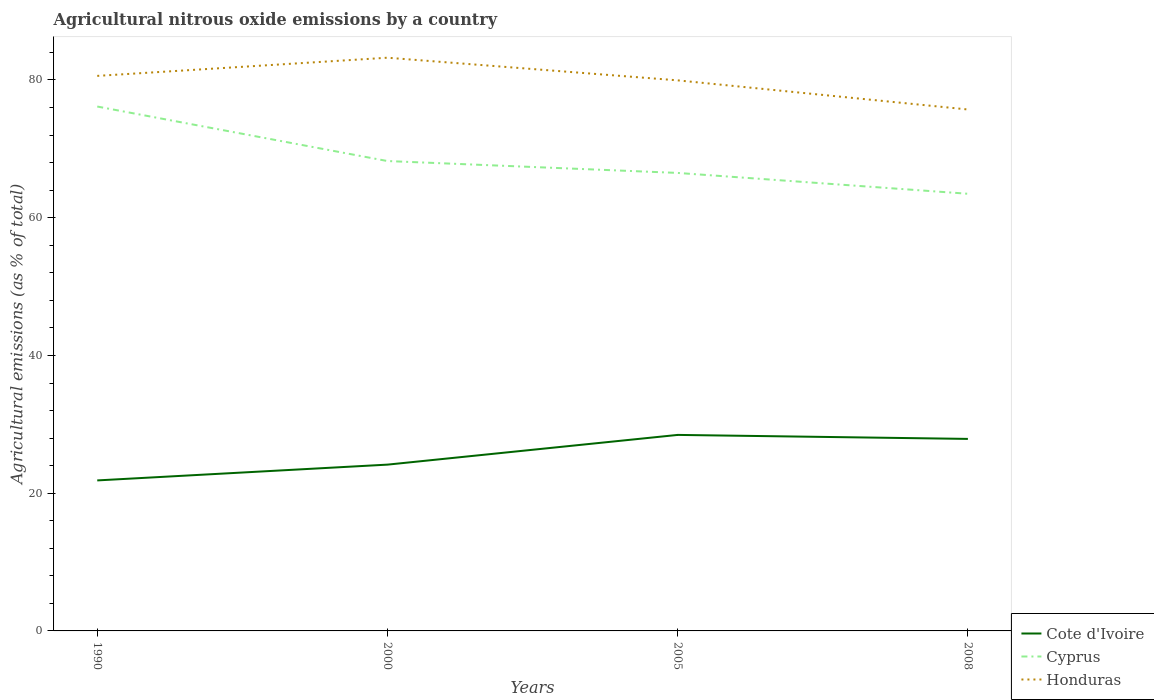How many different coloured lines are there?
Provide a succinct answer. 3. Across all years, what is the maximum amount of agricultural nitrous oxide emitted in Honduras?
Provide a short and direct response. 75.72. In which year was the amount of agricultural nitrous oxide emitted in Honduras maximum?
Your answer should be compact. 2008. What is the total amount of agricultural nitrous oxide emitted in Cote d'Ivoire in the graph?
Give a very brief answer. -4.31. What is the difference between the highest and the second highest amount of agricultural nitrous oxide emitted in Cyprus?
Provide a succinct answer. 12.67. What is the difference between the highest and the lowest amount of agricultural nitrous oxide emitted in Cote d'Ivoire?
Offer a very short reply. 2. Is the amount of agricultural nitrous oxide emitted in Honduras strictly greater than the amount of agricultural nitrous oxide emitted in Cyprus over the years?
Give a very brief answer. No. What is the difference between two consecutive major ticks on the Y-axis?
Keep it short and to the point. 20. Are the values on the major ticks of Y-axis written in scientific E-notation?
Your answer should be compact. No. Does the graph contain any zero values?
Provide a short and direct response. No. How many legend labels are there?
Keep it short and to the point. 3. What is the title of the graph?
Your answer should be very brief. Agricultural nitrous oxide emissions by a country. What is the label or title of the X-axis?
Make the answer very short. Years. What is the label or title of the Y-axis?
Your answer should be very brief. Agricultural emissions (as % of total). What is the Agricultural emissions (as % of total) in Cote d'Ivoire in 1990?
Your response must be concise. 21.85. What is the Agricultural emissions (as % of total) of Cyprus in 1990?
Your answer should be very brief. 76.14. What is the Agricultural emissions (as % of total) in Honduras in 1990?
Give a very brief answer. 80.59. What is the Agricultural emissions (as % of total) of Cote d'Ivoire in 2000?
Provide a short and direct response. 24.15. What is the Agricultural emissions (as % of total) in Cyprus in 2000?
Provide a short and direct response. 68.23. What is the Agricultural emissions (as % of total) of Honduras in 2000?
Offer a very short reply. 83.23. What is the Agricultural emissions (as % of total) in Cote d'Ivoire in 2005?
Your response must be concise. 28.46. What is the Agricultural emissions (as % of total) in Cyprus in 2005?
Offer a very short reply. 66.5. What is the Agricultural emissions (as % of total) in Honduras in 2005?
Offer a terse response. 79.95. What is the Agricultural emissions (as % of total) of Cote d'Ivoire in 2008?
Your response must be concise. 27.88. What is the Agricultural emissions (as % of total) in Cyprus in 2008?
Your answer should be very brief. 63.48. What is the Agricultural emissions (as % of total) of Honduras in 2008?
Keep it short and to the point. 75.72. Across all years, what is the maximum Agricultural emissions (as % of total) of Cote d'Ivoire?
Offer a very short reply. 28.46. Across all years, what is the maximum Agricultural emissions (as % of total) of Cyprus?
Your answer should be compact. 76.14. Across all years, what is the maximum Agricultural emissions (as % of total) in Honduras?
Offer a very short reply. 83.23. Across all years, what is the minimum Agricultural emissions (as % of total) of Cote d'Ivoire?
Provide a succinct answer. 21.85. Across all years, what is the minimum Agricultural emissions (as % of total) in Cyprus?
Provide a short and direct response. 63.48. Across all years, what is the minimum Agricultural emissions (as % of total) in Honduras?
Your response must be concise. 75.72. What is the total Agricultural emissions (as % of total) of Cote d'Ivoire in the graph?
Provide a short and direct response. 102.34. What is the total Agricultural emissions (as % of total) in Cyprus in the graph?
Provide a short and direct response. 274.36. What is the total Agricultural emissions (as % of total) in Honduras in the graph?
Offer a terse response. 319.49. What is the difference between the Agricultural emissions (as % of total) of Cote d'Ivoire in 1990 and that in 2000?
Offer a terse response. -2.29. What is the difference between the Agricultural emissions (as % of total) in Cyprus in 1990 and that in 2000?
Your answer should be very brief. 7.92. What is the difference between the Agricultural emissions (as % of total) in Honduras in 1990 and that in 2000?
Your response must be concise. -2.64. What is the difference between the Agricultural emissions (as % of total) in Cote d'Ivoire in 1990 and that in 2005?
Keep it short and to the point. -6.61. What is the difference between the Agricultural emissions (as % of total) of Cyprus in 1990 and that in 2005?
Your answer should be very brief. 9.64. What is the difference between the Agricultural emissions (as % of total) in Honduras in 1990 and that in 2005?
Offer a very short reply. 0.65. What is the difference between the Agricultural emissions (as % of total) of Cote d'Ivoire in 1990 and that in 2008?
Your answer should be very brief. -6.03. What is the difference between the Agricultural emissions (as % of total) of Cyprus in 1990 and that in 2008?
Offer a terse response. 12.67. What is the difference between the Agricultural emissions (as % of total) in Honduras in 1990 and that in 2008?
Ensure brevity in your answer.  4.88. What is the difference between the Agricultural emissions (as % of total) in Cote d'Ivoire in 2000 and that in 2005?
Make the answer very short. -4.31. What is the difference between the Agricultural emissions (as % of total) in Cyprus in 2000 and that in 2005?
Give a very brief answer. 1.73. What is the difference between the Agricultural emissions (as % of total) in Honduras in 2000 and that in 2005?
Make the answer very short. 3.29. What is the difference between the Agricultural emissions (as % of total) in Cote d'Ivoire in 2000 and that in 2008?
Your answer should be compact. -3.73. What is the difference between the Agricultural emissions (as % of total) in Cyprus in 2000 and that in 2008?
Give a very brief answer. 4.75. What is the difference between the Agricultural emissions (as % of total) of Honduras in 2000 and that in 2008?
Offer a very short reply. 7.52. What is the difference between the Agricultural emissions (as % of total) of Cote d'Ivoire in 2005 and that in 2008?
Provide a short and direct response. 0.58. What is the difference between the Agricultural emissions (as % of total) in Cyprus in 2005 and that in 2008?
Make the answer very short. 3.03. What is the difference between the Agricultural emissions (as % of total) in Honduras in 2005 and that in 2008?
Offer a very short reply. 4.23. What is the difference between the Agricultural emissions (as % of total) in Cote d'Ivoire in 1990 and the Agricultural emissions (as % of total) in Cyprus in 2000?
Provide a short and direct response. -46.38. What is the difference between the Agricultural emissions (as % of total) in Cote d'Ivoire in 1990 and the Agricultural emissions (as % of total) in Honduras in 2000?
Provide a short and direct response. -61.38. What is the difference between the Agricultural emissions (as % of total) in Cyprus in 1990 and the Agricultural emissions (as % of total) in Honduras in 2000?
Your answer should be compact. -7.09. What is the difference between the Agricultural emissions (as % of total) in Cote d'Ivoire in 1990 and the Agricultural emissions (as % of total) in Cyprus in 2005?
Ensure brevity in your answer.  -44.65. What is the difference between the Agricultural emissions (as % of total) in Cote d'Ivoire in 1990 and the Agricultural emissions (as % of total) in Honduras in 2005?
Your answer should be very brief. -58.09. What is the difference between the Agricultural emissions (as % of total) of Cyprus in 1990 and the Agricultural emissions (as % of total) of Honduras in 2005?
Offer a very short reply. -3.8. What is the difference between the Agricultural emissions (as % of total) in Cote d'Ivoire in 1990 and the Agricultural emissions (as % of total) in Cyprus in 2008?
Offer a terse response. -41.62. What is the difference between the Agricultural emissions (as % of total) of Cote d'Ivoire in 1990 and the Agricultural emissions (as % of total) of Honduras in 2008?
Offer a terse response. -53.86. What is the difference between the Agricultural emissions (as % of total) of Cyprus in 1990 and the Agricultural emissions (as % of total) of Honduras in 2008?
Your response must be concise. 0.43. What is the difference between the Agricultural emissions (as % of total) of Cote d'Ivoire in 2000 and the Agricultural emissions (as % of total) of Cyprus in 2005?
Keep it short and to the point. -42.36. What is the difference between the Agricultural emissions (as % of total) in Cote d'Ivoire in 2000 and the Agricultural emissions (as % of total) in Honduras in 2005?
Your answer should be compact. -55.8. What is the difference between the Agricultural emissions (as % of total) in Cyprus in 2000 and the Agricultural emissions (as % of total) in Honduras in 2005?
Ensure brevity in your answer.  -11.72. What is the difference between the Agricultural emissions (as % of total) in Cote d'Ivoire in 2000 and the Agricultural emissions (as % of total) in Cyprus in 2008?
Give a very brief answer. -39.33. What is the difference between the Agricultural emissions (as % of total) in Cote d'Ivoire in 2000 and the Agricultural emissions (as % of total) in Honduras in 2008?
Provide a short and direct response. -51.57. What is the difference between the Agricultural emissions (as % of total) in Cyprus in 2000 and the Agricultural emissions (as % of total) in Honduras in 2008?
Provide a short and direct response. -7.49. What is the difference between the Agricultural emissions (as % of total) in Cote d'Ivoire in 2005 and the Agricultural emissions (as % of total) in Cyprus in 2008?
Ensure brevity in your answer.  -35.02. What is the difference between the Agricultural emissions (as % of total) of Cote d'Ivoire in 2005 and the Agricultural emissions (as % of total) of Honduras in 2008?
Your answer should be very brief. -47.25. What is the difference between the Agricultural emissions (as % of total) of Cyprus in 2005 and the Agricultural emissions (as % of total) of Honduras in 2008?
Give a very brief answer. -9.21. What is the average Agricultural emissions (as % of total) of Cote d'Ivoire per year?
Offer a very short reply. 25.59. What is the average Agricultural emissions (as % of total) in Cyprus per year?
Offer a terse response. 68.59. What is the average Agricultural emissions (as % of total) in Honduras per year?
Keep it short and to the point. 79.87. In the year 1990, what is the difference between the Agricultural emissions (as % of total) in Cote d'Ivoire and Agricultural emissions (as % of total) in Cyprus?
Provide a short and direct response. -54.29. In the year 1990, what is the difference between the Agricultural emissions (as % of total) in Cote d'Ivoire and Agricultural emissions (as % of total) in Honduras?
Offer a very short reply. -58.74. In the year 1990, what is the difference between the Agricultural emissions (as % of total) of Cyprus and Agricultural emissions (as % of total) of Honduras?
Your response must be concise. -4.45. In the year 2000, what is the difference between the Agricultural emissions (as % of total) of Cote d'Ivoire and Agricultural emissions (as % of total) of Cyprus?
Your response must be concise. -44.08. In the year 2000, what is the difference between the Agricultural emissions (as % of total) of Cote d'Ivoire and Agricultural emissions (as % of total) of Honduras?
Provide a succinct answer. -59.09. In the year 2000, what is the difference between the Agricultural emissions (as % of total) of Cyprus and Agricultural emissions (as % of total) of Honduras?
Give a very brief answer. -15. In the year 2005, what is the difference between the Agricultural emissions (as % of total) in Cote d'Ivoire and Agricultural emissions (as % of total) in Cyprus?
Provide a short and direct response. -38.04. In the year 2005, what is the difference between the Agricultural emissions (as % of total) of Cote d'Ivoire and Agricultural emissions (as % of total) of Honduras?
Your answer should be very brief. -51.49. In the year 2005, what is the difference between the Agricultural emissions (as % of total) in Cyprus and Agricultural emissions (as % of total) in Honduras?
Provide a short and direct response. -13.44. In the year 2008, what is the difference between the Agricultural emissions (as % of total) in Cote d'Ivoire and Agricultural emissions (as % of total) in Cyprus?
Your answer should be compact. -35.6. In the year 2008, what is the difference between the Agricultural emissions (as % of total) of Cote d'Ivoire and Agricultural emissions (as % of total) of Honduras?
Your response must be concise. -47.84. In the year 2008, what is the difference between the Agricultural emissions (as % of total) of Cyprus and Agricultural emissions (as % of total) of Honduras?
Keep it short and to the point. -12.24. What is the ratio of the Agricultural emissions (as % of total) in Cote d'Ivoire in 1990 to that in 2000?
Keep it short and to the point. 0.91. What is the ratio of the Agricultural emissions (as % of total) in Cyprus in 1990 to that in 2000?
Your answer should be very brief. 1.12. What is the ratio of the Agricultural emissions (as % of total) in Honduras in 1990 to that in 2000?
Provide a succinct answer. 0.97. What is the ratio of the Agricultural emissions (as % of total) of Cote d'Ivoire in 1990 to that in 2005?
Offer a very short reply. 0.77. What is the ratio of the Agricultural emissions (as % of total) of Cyprus in 1990 to that in 2005?
Offer a terse response. 1.15. What is the ratio of the Agricultural emissions (as % of total) of Cote d'Ivoire in 1990 to that in 2008?
Your answer should be compact. 0.78. What is the ratio of the Agricultural emissions (as % of total) of Cyprus in 1990 to that in 2008?
Offer a terse response. 1.2. What is the ratio of the Agricultural emissions (as % of total) in Honduras in 1990 to that in 2008?
Keep it short and to the point. 1.06. What is the ratio of the Agricultural emissions (as % of total) of Cote d'Ivoire in 2000 to that in 2005?
Offer a terse response. 0.85. What is the ratio of the Agricultural emissions (as % of total) of Cyprus in 2000 to that in 2005?
Your response must be concise. 1.03. What is the ratio of the Agricultural emissions (as % of total) in Honduras in 2000 to that in 2005?
Offer a terse response. 1.04. What is the ratio of the Agricultural emissions (as % of total) in Cote d'Ivoire in 2000 to that in 2008?
Your answer should be very brief. 0.87. What is the ratio of the Agricultural emissions (as % of total) in Cyprus in 2000 to that in 2008?
Offer a terse response. 1.07. What is the ratio of the Agricultural emissions (as % of total) of Honduras in 2000 to that in 2008?
Make the answer very short. 1.1. What is the ratio of the Agricultural emissions (as % of total) in Cote d'Ivoire in 2005 to that in 2008?
Your answer should be very brief. 1.02. What is the ratio of the Agricultural emissions (as % of total) in Cyprus in 2005 to that in 2008?
Provide a short and direct response. 1.05. What is the ratio of the Agricultural emissions (as % of total) of Honduras in 2005 to that in 2008?
Your response must be concise. 1.06. What is the difference between the highest and the second highest Agricultural emissions (as % of total) of Cote d'Ivoire?
Give a very brief answer. 0.58. What is the difference between the highest and the second highest Agricultural emissions (as % of total) of Cyprus?
Your answer should be very brief. 7.92. What is the difference between the highest and the second highest Agricultural emissions (as % of total) in Honduras?
Provide a succinct answer. 2.64. What is the difference between the highest and the lowest Agricultural emissions (as % of total) in Cote d'Ivoire?
Make the answer very short. 6.61. What is the difference between the highest and the lowest Agricultural emissions (as % of total) in Cyprus?
Provide a short and direct response. 12.67. What is the difference between the highest and the lowest Agricultural emissions (as % of total) in Honduras?
Offer a terse response. 7.52. 